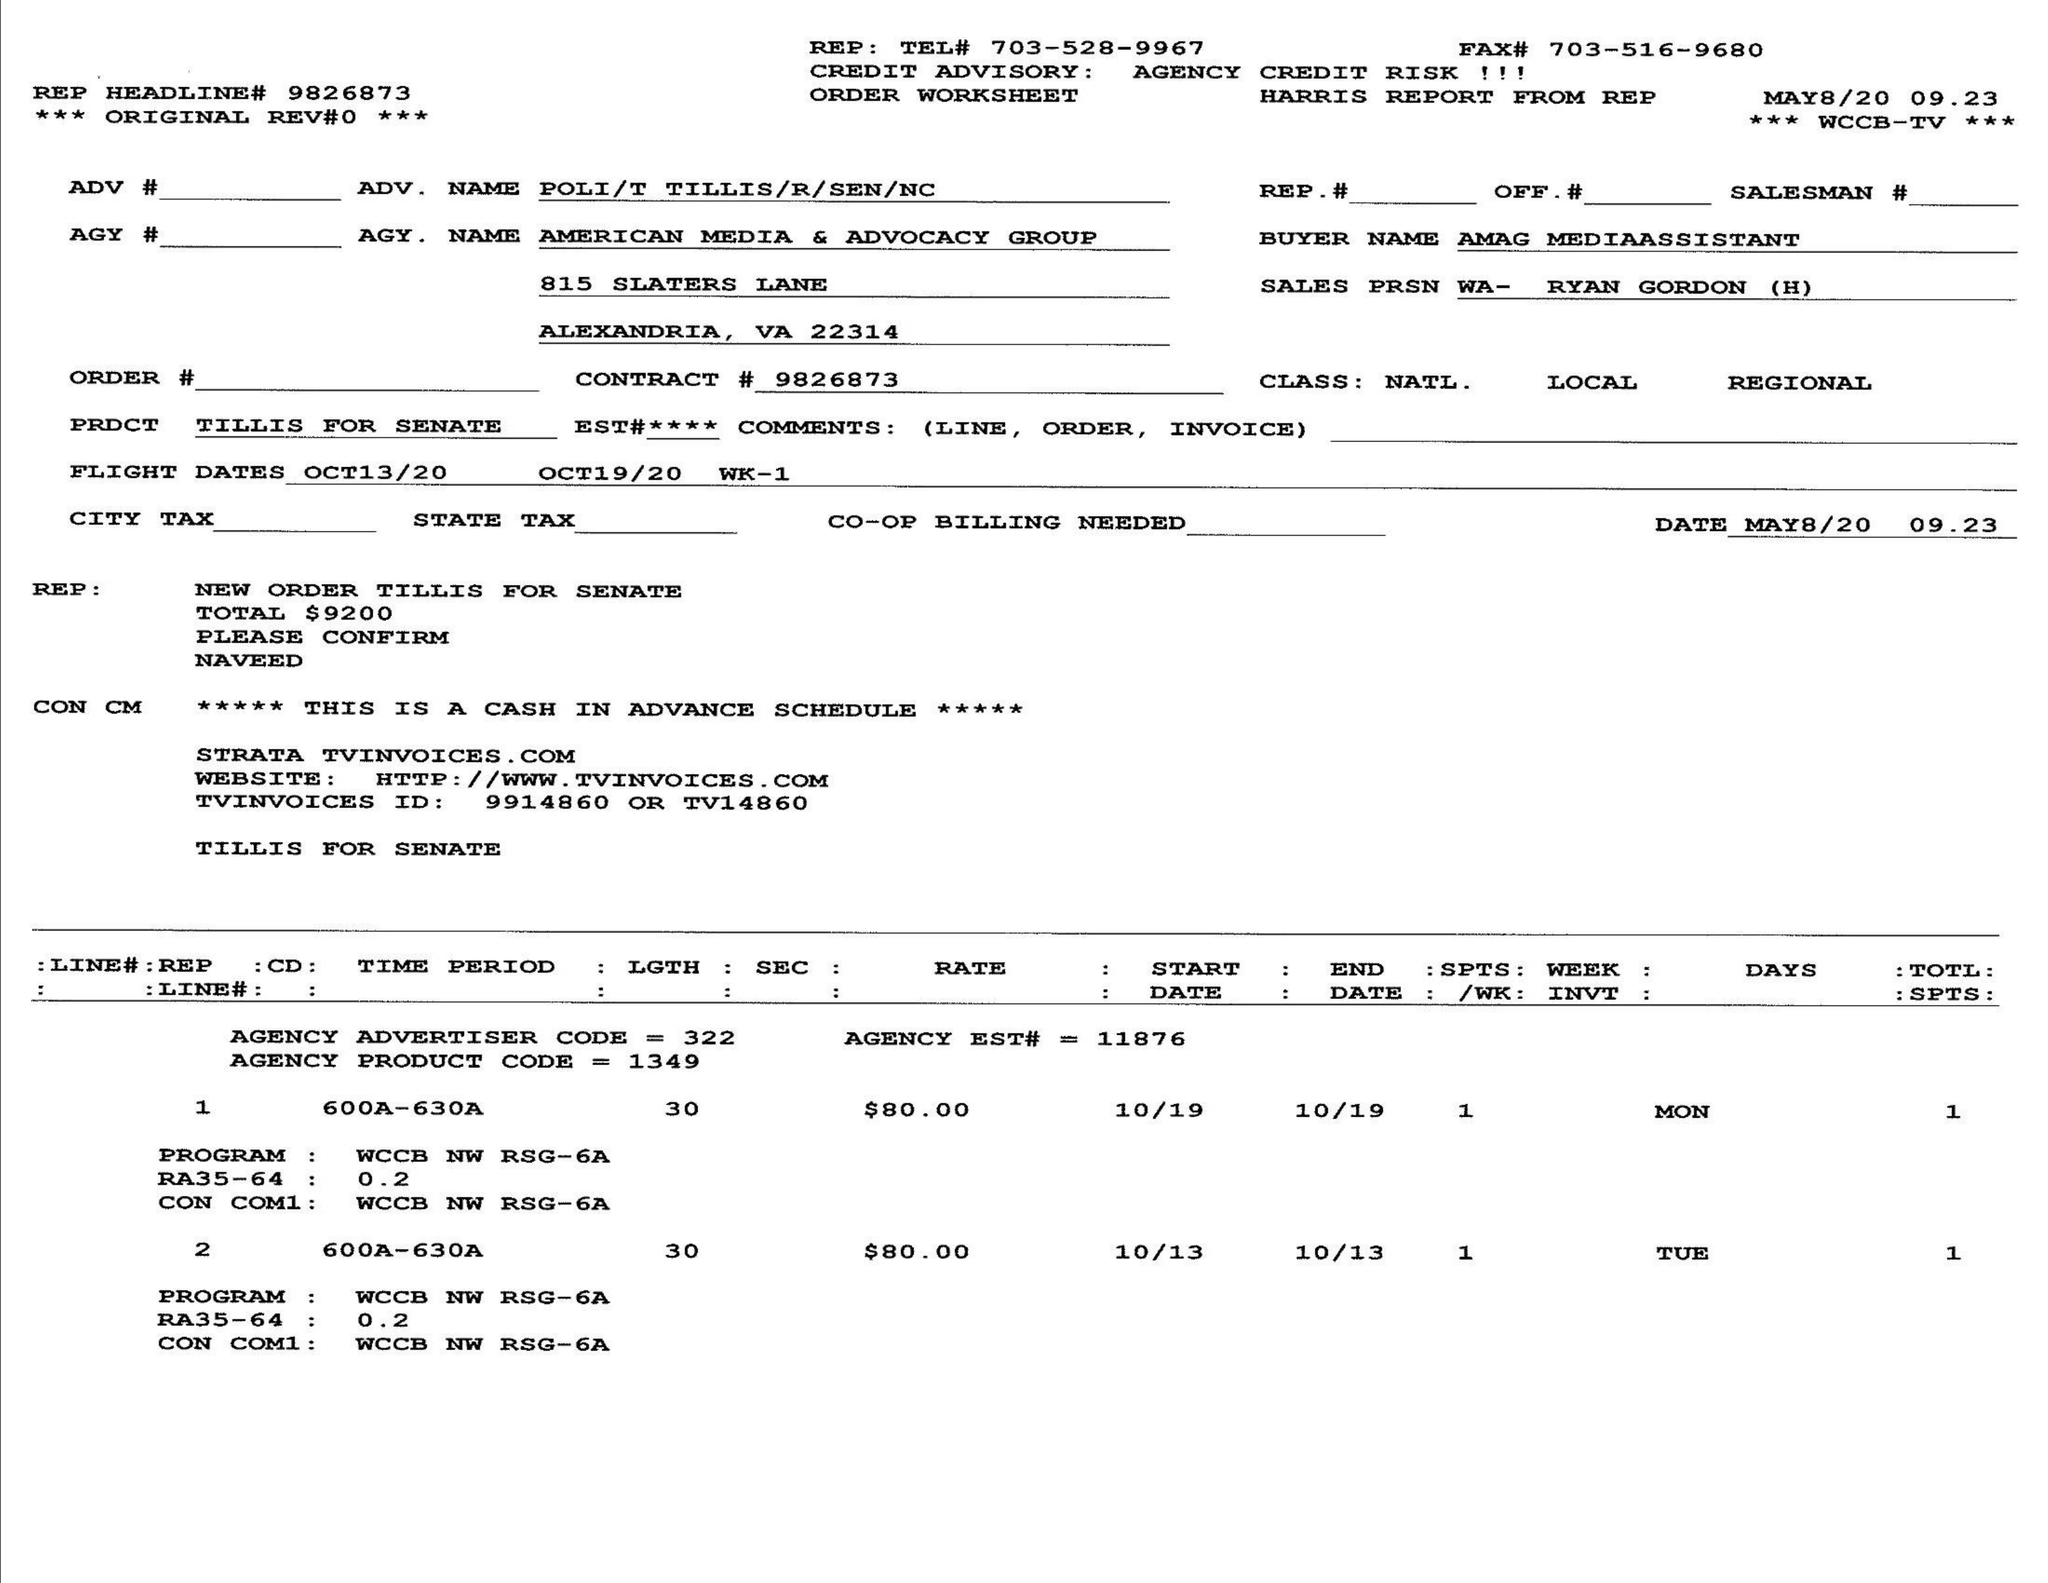What is the value for the gross_amount?
Answer the question using a single word or phrase. 9200.00 